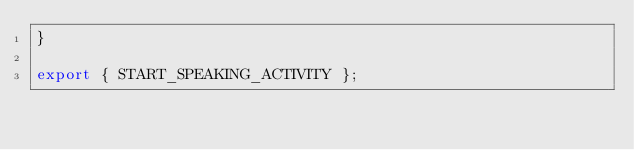<code> <loc_0><loc_0><loc_500><loc_500><_JavaScript_>}

export { START_SPEAKING_ACTIVITY };
</code> 